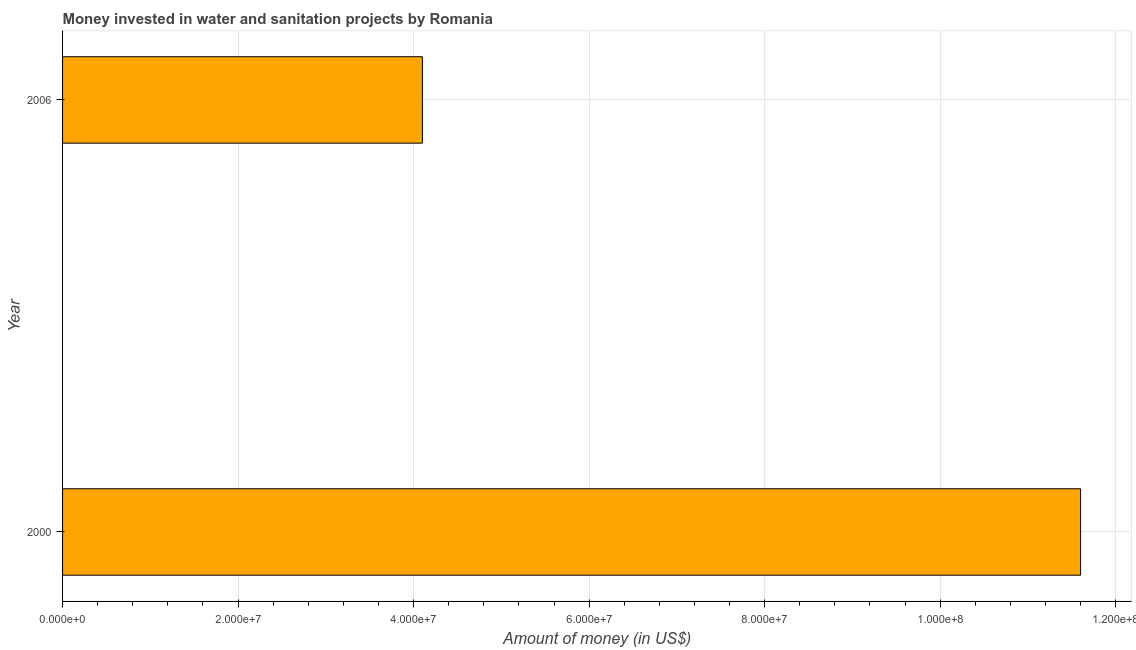Does the graph contain any zero values?
Offer a terse response. No. What is the title of the graph?
Keep it short and to the point. Money invested in water and sanitation projects by Romania. What is the label or title of the X-axis?
Keep it short and to the point. Amount of money (in US$). What is the label or title of the Y-axis?
Provide a short and direct response. Year. What is the investment in 2006?
Make the answer very short. 4.10e+07. Across all years, what is the maximum investment?
Your answer should be very brief. 1.16e+08. Across all years, what is the minimum investment?
Offer a terse response. 4.10e+07. What is the sum of the investment?
Your response must be concise. 1.57e+08. What is the difference between the investment in 2000 and 2006?
Offer a terse response. 7.50e+07. What is the average investment per year?
Your response must be concise. 7.85e+07. What is the median investment?
Your response must be concise. 7.85e+07. What is the ratio of the investment in 2000 to that in 2006?
Offer a very short reply. 2.83. In how many years, is the investment greater than the average investment taken over all years?
Your response must be concise. 1. Are the values on the major ticks of X-axis written in scientific E-notation?
Offer a terse response. Yes. What is the Amount of money (in US$) in 2000?
Give a very brief answer. 1.16e+08. What is the Amount of money (in US$) in 2006?
Your answer should be compact. 4.10e+07. What is the difference between the Amount of money (in US$) in 2000 and 2006?
Give a very brief answer. 7.50e+07. What is the ratio of the Amount of money (in US$) in 2000 to that in 2006?
Your response must be concise. 2.83. 